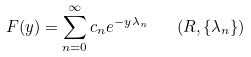<formula> <loc_0><loc_0><loc_500><loc_500>F ( y ) = \sum ^ { \infty } _ { n = 0 } c _ { n } e ^ { - y \lambda _ { n } } \quad ( R , \left \{ \lambda _ { n } \right \} ) \</formula> 